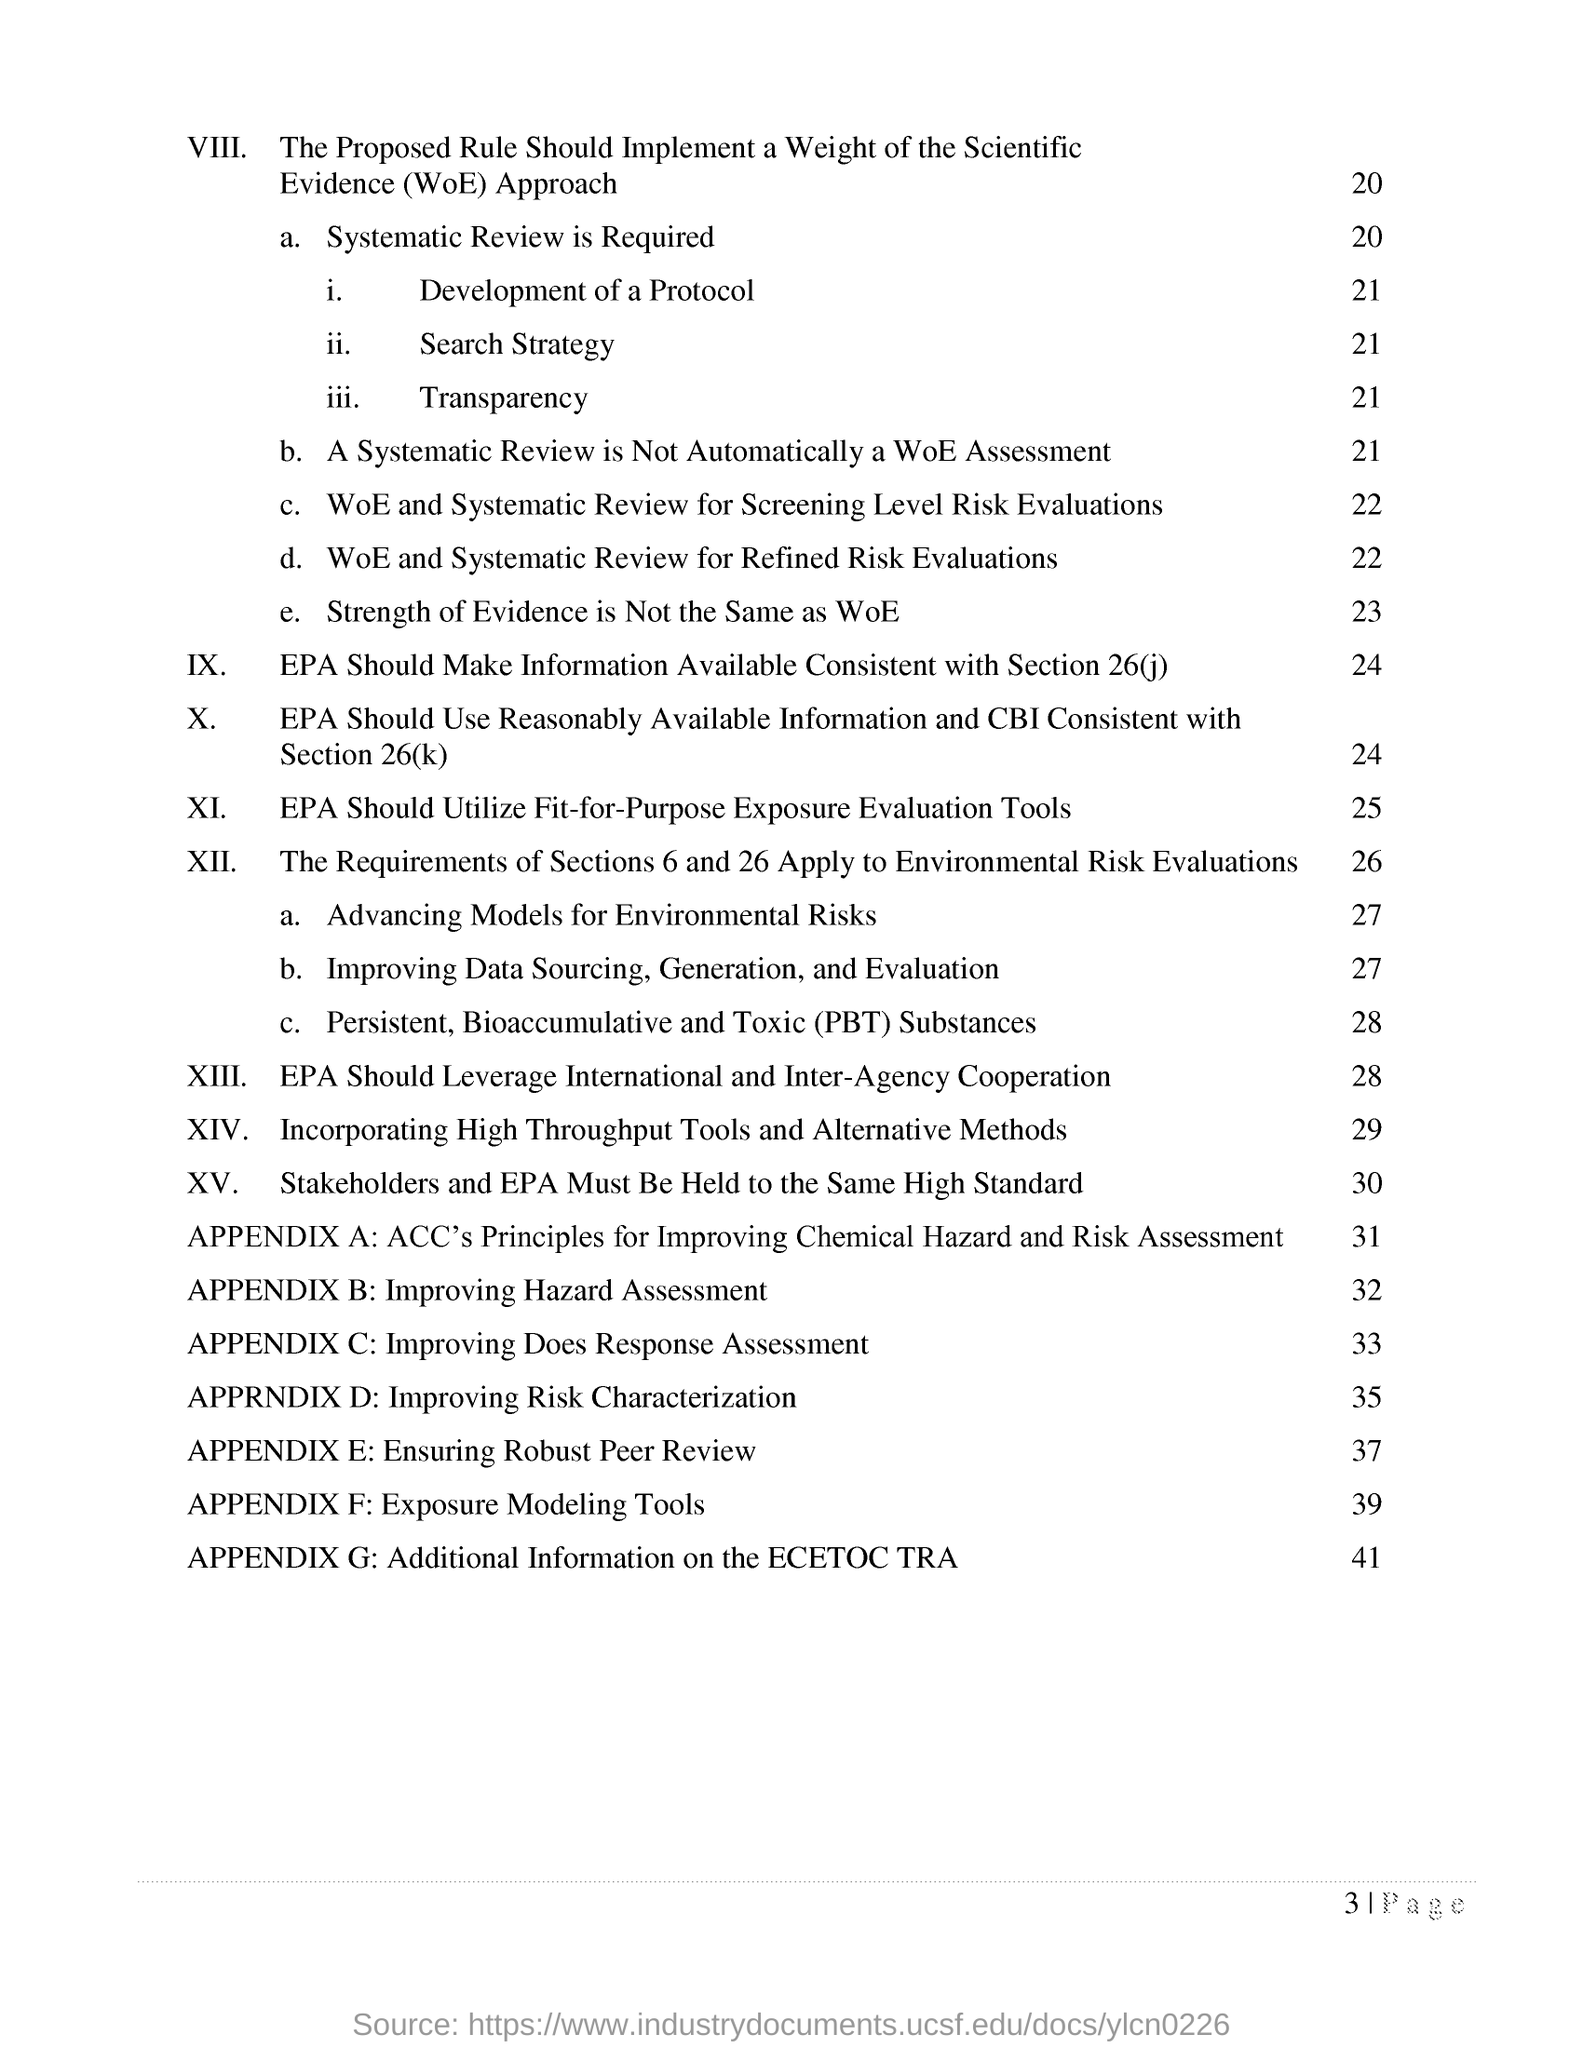What is the title of appendix b?
Your answer should be very brief. Improving hazard assesment. What is the page number of 'incorporating high throughput tools and alternative methods'?
Make the answer very short. 29. 